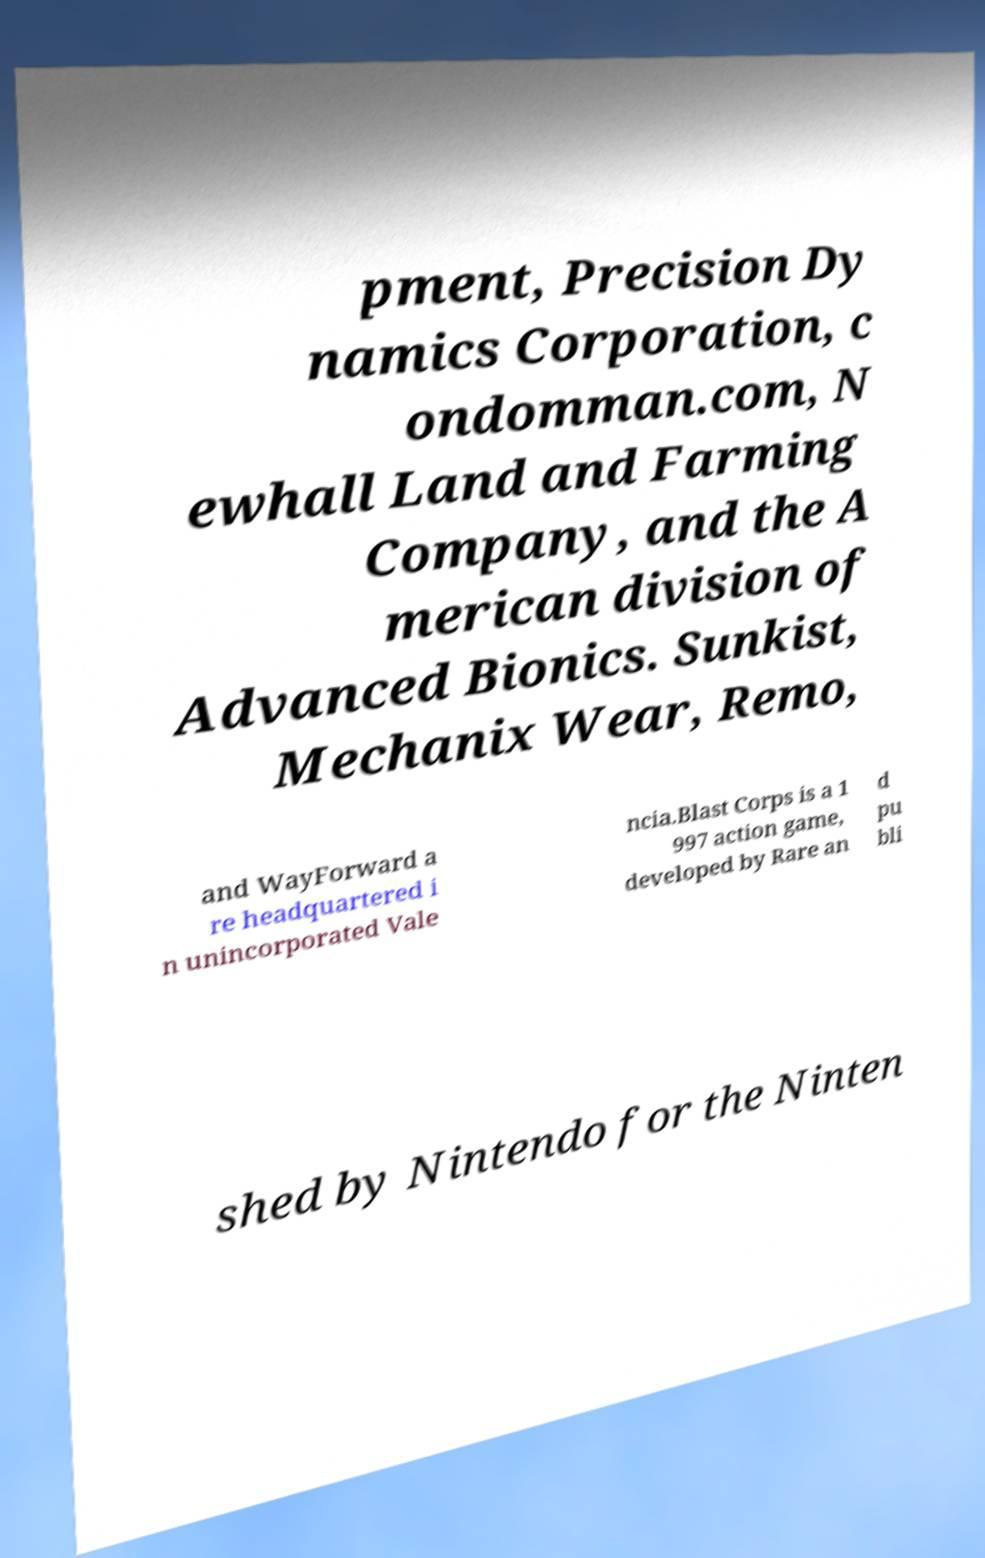Could you extract and type out the text from this image? pment, Precision Dy namics Corporation, c ondomman.com, N ewhall Land and Farming Company, and the A merican division of Advanced Bionics. Sunkist, Mechanix Wear, Remo, and WayForward a re headquartered i n unincorporated Vale ncia.Blast Corps is a 1 997 action game, developed by Rare an d pu bli shed by Nintendo for the Ninten 